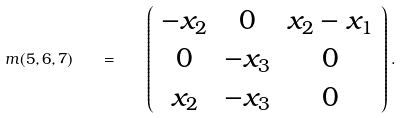Convert formula to latex. <formula><loc_0><loc_0><loc_500><loc_500>m ( 5 , 6 , 7 ) \quad = \quad \left ( \begin{array} { c c c } - x _ { 2 } & 0 & x _ { 2 } - x _ { 1 } \\ 0 & - x _ { 3 } & 0 \\ x _ { 2 } & - x _ { 3 } & 0 \end{array} \right ) .</formula> 